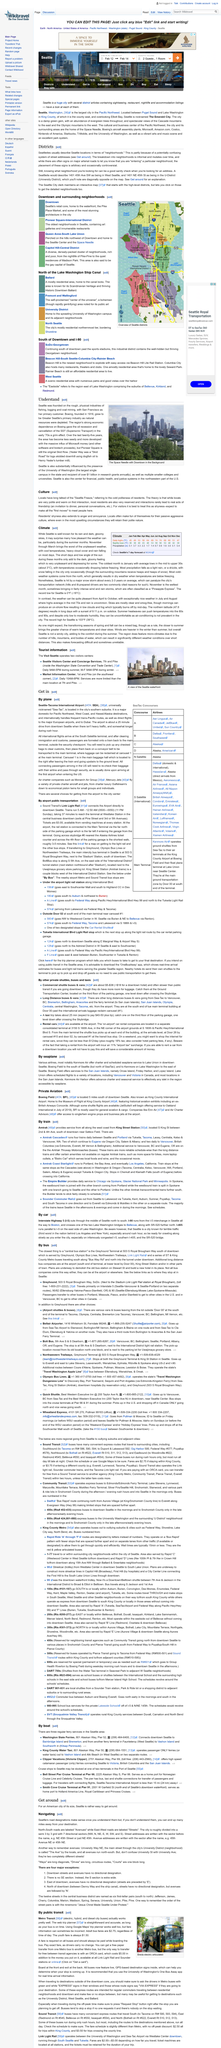Identify some key points in this picture. The above image depicts the Space Needle, with Downtown visible in the background. Seattle was founded on the rugged and industrious activities of fishing, logging, and coal mining. The city is divided into a semi-3 by 3 grid with 7 directional sectors. Each sector is represented by an arrow pointing in the corresponding direction, with the exception of the top sector, which is represented by a cross. The sectors are located on the corners of a square with a 6-unit diameter. The directional sectors are labeled A through G. Kenmore Air provides scheduled seaplane services to Lake Union from various locations. Seattle is located in the northwestern part of the United States, and it is a hub for financial, public health, and justice systems. 